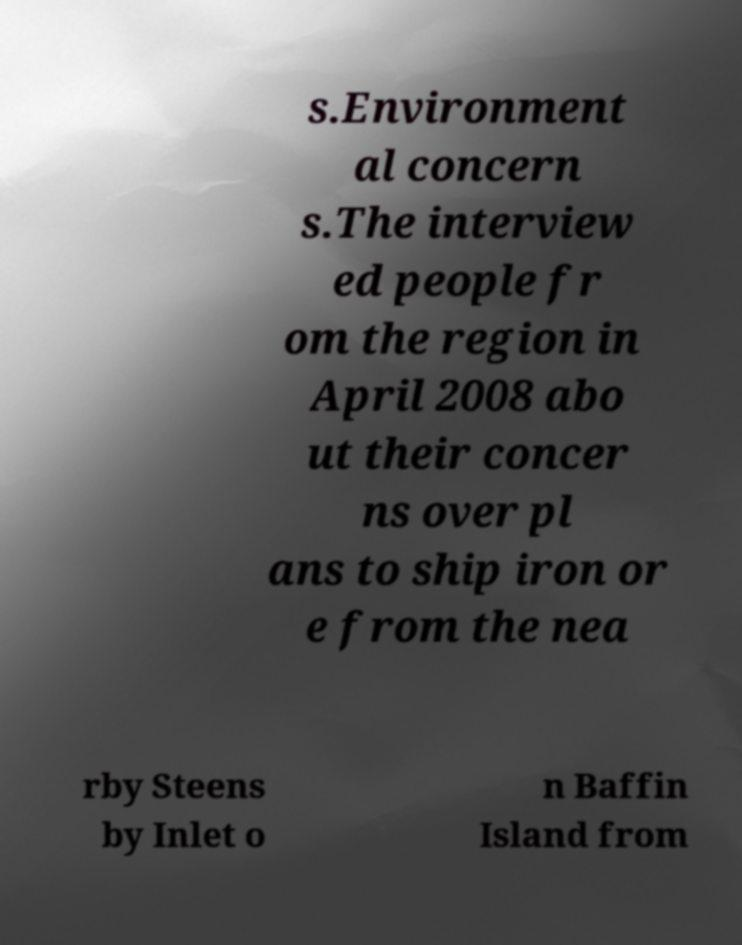Can you read and provide the text displayed in the image?This photo seems to have some interesting text. Can you extract and type it out for me? s.Environment al concern s.The interview ed people fr om the region in April 2008 abo ut their concer ns over pl ans to ship iron or e from the nea rby Steens by Inlet o n Baffin Island from 